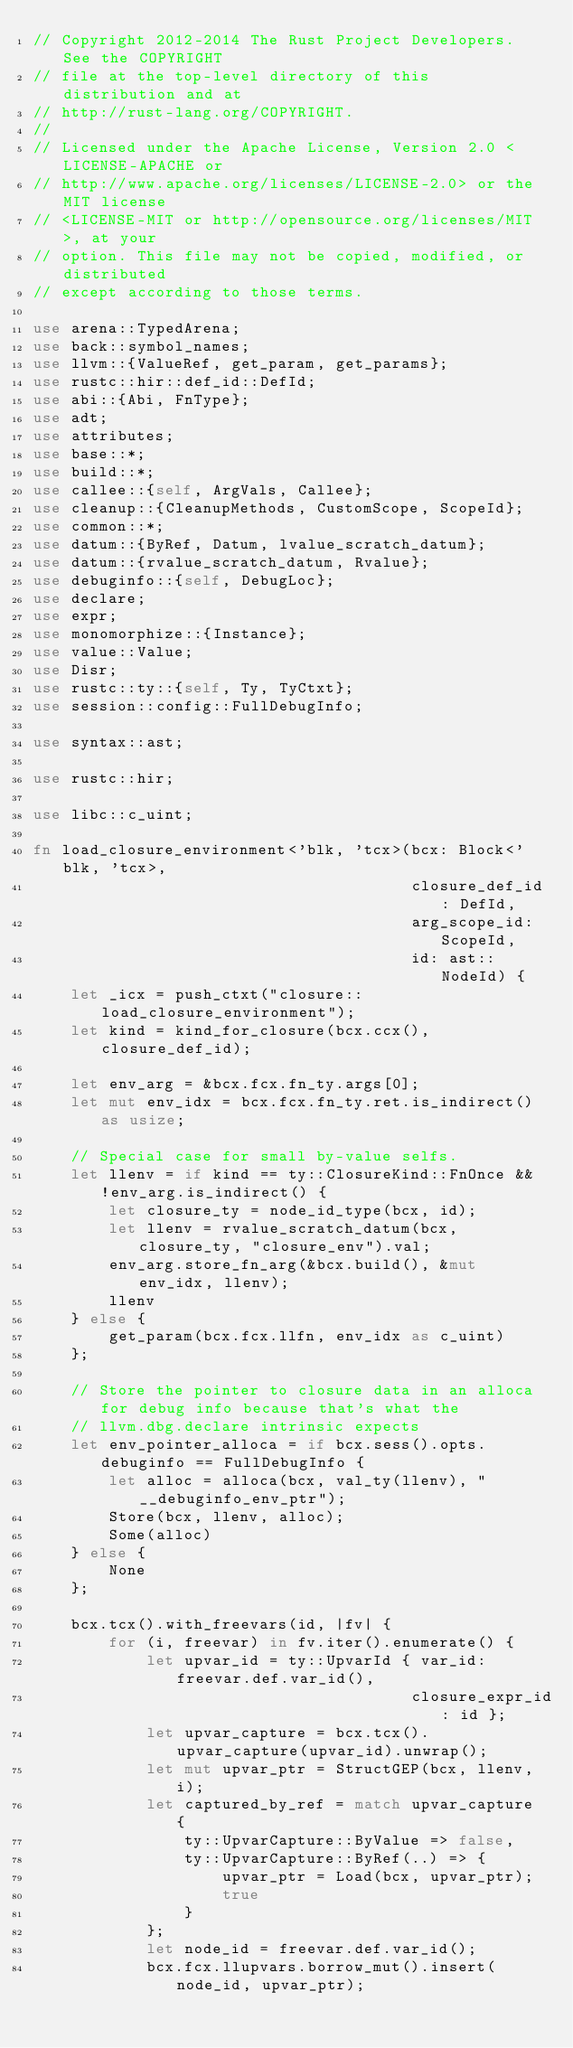Convert code to text. <code><loc_0><loc_0><loc_500><loc_500><_Rust_>// Copyright 2012-2014 The Rust Project Developers. See the COPYRIGHT
// file at the top-level directory of this distribution and at
// http://rust-lang.org/COPYRIGHT.
//
// Licensed under the Apache License, Version 2.0 <LICENSE-APACHE or
// http://www.apache.org/licenses/LICENSE-2.0> or the MIT license
// <LICENSE-MIT or http://opensource.org/licenses/MIT>, at your
// option. This file may not be copied, modified, or distributed
// except according to those terms.

use arena::TypedArena;
use back::symbol_names;
use llvm::{ValueRef, get_param, get_params};
use rustc::hir::def_id::DefId;
use abi::{Abi, FnType};
use adt;
use attributes;
use base::*;
use build::*;
use callee::{self, ArgVals, Callee};
use cleanup::{CleanupMethods, CustomScope, ScopeId};
use common::*;
use datum::{ByRef, Datum, lvalue_scratch_datum};
use datum::{rvalue_scratch_datum, Rvalue};
use debuginfo::{self, DebugLoc};
use declare;
use expr;
use monomorphize::{Instance};
use value::Value;
use Disr;
use rustc::ty::{self, Ty, TyCtxt};
use session::config::FullDebugInfo;

use syntax::ast;

use rustc::hir;

use libc::c_uint;

fn load_closure_environment<'blk, 'tcx>(bcx: Block<'blk, 'tcx>,
                                        closure_def_id: DefId,
                                        arg_scope_id: ScopeId,
                                        id: ast::NodeId) {
    let _icx = push_ctxt("closure::load_closure_environment");
    let kind = kind_for_closure(bcx.ccx(), closure_def_id);

    let env_arg = &bcx.fcx.fn_ty.args[0];
    let mut env_idx = bcx.fcx.fn_ty.ret.is_indirect() as usize;

    // Special case for small by-value selfs.
    let llenv = if kind == ty::ClosureKind::FnOnce && !env_arg.is_indirect() {
        let closure_ty = node_id_type(bcx, id);
        let llenv = rvalue_scratch_datum(bcx, closure_ty, "closure_env").val;
        env_arg.store_fn_arg(&bcx.build(), &mut env_idx, llenv);
        llenv
    } else {
        get_param(bcx.fcx.llfn, env_idx as c_uint)
    };

    // Store the pointer to closure data in an alloca for debug info because that's what the
    // llvm.dbg.declare intrinsic expects
    let env_pointer_alloca = if bcx.sess().opts.debuginfo == FullDebugInfo {
        let alloc = alloca(bcx, val_ty(llenv), "__debuginfo_env_ptr");
        Store(bcx, llenv, alloc);
        Some(alloc)
    } else {
        None
    };

    bcx.tcx().with_freevars(id, |fv| {
        for (i, freevar) in fv.iter().enumerate() {
            let upvar_id = ty::UpvarId { var_id: freevar.def.var_id(),
                                        closure_expr_id: id };
            let upvar_capture = bcx.tcx().upvar_capture(upvar_id).unwrap();
            let mut upvar_ptr = StructGEP(bcx, llenv, i);
            let captured_by_ref = match upvar_capture {
                ty::UpvarCapture::ByValue => false,
                ty::UpvarCapture::ByRef(..) => {
                    upvar_ptr = Load(bcx, upvar_ptr);
                    true
                }
            };
            let node_id = freevar.def.var_id();
            bcx.fcx.llupvars.borrow_mut().insert(node_id, upvar_ptr);
</code> 